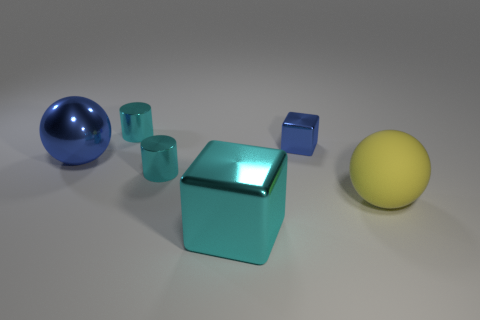Is the number of large yellow rubber balls in front of the big cyan block less than the number of green rubber cubes? no 